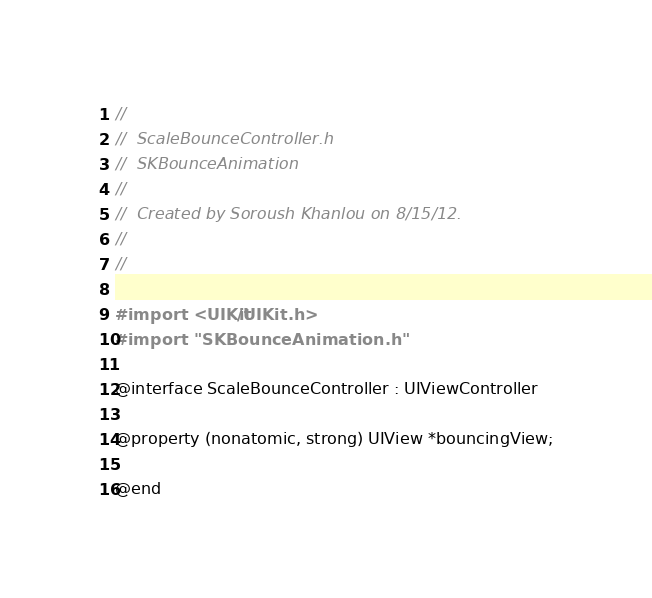Convert code to text. <code><loc_0><loc_0><loc_500><loc_500><_C_>//
//  ScaleBounceController.h
//  SKBounceAnimation
//
//  Created by Soroush Khanlou on 8/15/12.
//
//

#import <UIKit/UIKit.h>
#import "SKBounceAnimation.h"

@interface ScaleBounceController : UIViewController

@property (nonatomic, strong) UIView *bouncingView;

@end
</code> 